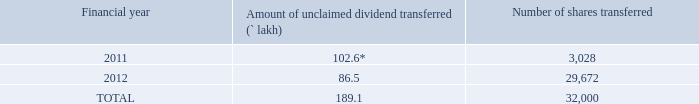Xvii. transfer of unclaimed/unpaid amounts to the investor education and protection fund:
pursuant to sections 124 and 125 of the act read with the investor education and protection fund authority (accounting, audit, transfer and refund) rules, 2016 (“iepf rules”), dividend, if not claimed for a consecutive period of 7 years from the date of transfer to unpaid dividend account of the company, are liable to be transferred to the investor education and protection fund (“iepf”).
further, all the shares in respect of which dividend has remained unclaimed for seven consecutive years or
more from the date of transfer to unpaid dividend account shall also be transferred to iepf authority. the said
requirement does not apply to shares in respect of which there is a specific order of court, tribunal or statutory
authority, restraining any transfer of the shares.
in the interest of the shareholders, the company sends periodical reminders to the shareholders to claim
their dividends in order to avoid transfer of dividends/shares to iepf authority. notices in this regard are also
published in the newspapers and the details of unclaimed dividends and shareholders whose shares are liable
to be transferred to the iepf authority, are uploaded on the company’s website (https://www.tcs.com/detailsunclaimed-
dividend-transfer-iepf-account-2017).
in light of the aforesaid provisions, the company has during the year under review, transferred to iepf the
unclaimed dividends, outstanding for 7 consecutive years, of the company, erstwhile tcs e-serve limited and
cmc limited (since amalgamated with the company). further, shares of the company, in respect of which
dividend has not been claimed for 7 consecutive years or more from the date of transfer to unpaid dividend
account, have also been transferred to the demat account of iepf authority.
the details of unclaimed dividends and shares transferred to iepf during fy 2019 are as follows:
* includes final dividend of erstwhile tcs e-serve limited and erstwhile cmc limited
the members who have a claim on above dividends and shares may claim the same from iepf authority by
submitting an online application in the prescribed form no. iepf-5 available on the website www.iepf.gov.
in and sending a physical copy of the same, duly signed to the company, along with requisite documents
enumerated in the form no. iepf-5. no claims shall lie against the company in respect of the dividend/shares
so transferred. the members/claimants can file only one consolidated claim in a financial year as per the iepf
rules.
what happens to dividends that are not claimed for a consecutive period of 7 years from the date of transfer to the company's unpaid dividend account? Liable to be transferred to the investor education and protection fund (“iepf”). How many shares from FY 2012 were transferred to IEPF in FY 2019? 29,672. How many consolidated claims can Members/Claimants file in a financial year? One. What is the increase in number of shares transferred to IEPF from 2011 to 2012? 29,672-3,028 
Answer: 26644. How many times is the number of shares transferred from FY 2012 that of 2011? 29,672/3,028 
Answer: 9.8. What is the percentage change in amount of unclaimed dividend? (102.6-86.5)/102.6 
Answer: 0.16. 